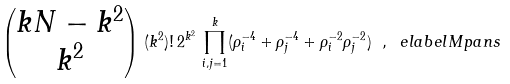<formula> <loc_0><loc_0><loc_500><loc_500>\begin{pmatrix} k N - k ^ { 2 } \\ k ^ { 2 } \end{pmatrix} \, ( k ^ { 2 } ) ! \, 2 ^ { k ^ { 2 } } \, \prod _ { i , j = 1 } ^ { k } ( \rho _ { i } ^ { - 4 } + \rho _ { j } ^ { - 4 } + \rho _ { i } ^ { - 2 } \rho _ { j } ^ { - 2 } ) \ , \ e l a b e l { M p a n s }</formula> 